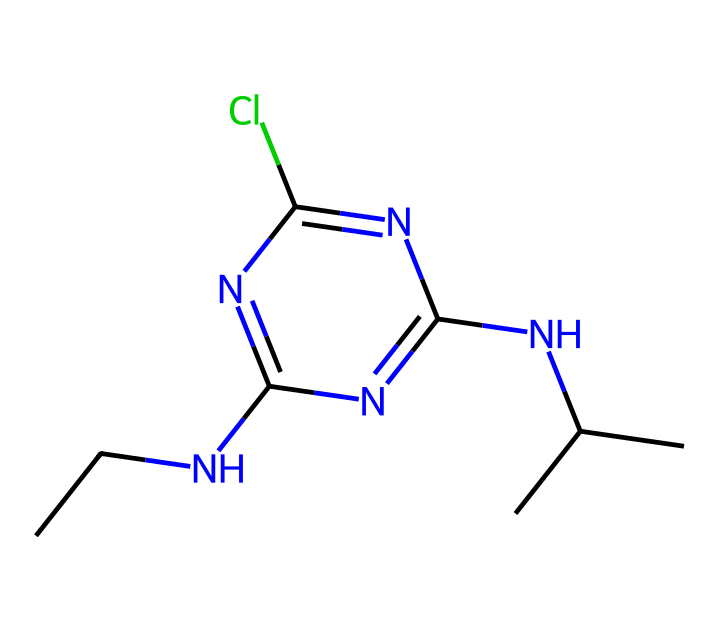What is the molecular formula of atrazine? The molecular formula can be derived from the SMILES representation by identifying the number of each type of atom present. In the provided SMILES, there are 10 carbons (C), 14 hydrogens (H), 3 nitrogens (N), 1 chlorine (Cl). Therefore, the molecular formula is C8H14ClN5.
Answer: C8H14ClN5 How many nitrogen atoms are present in the structure? By analyzing the SMILES representation, we can count the number of nitrogen (N) symbols present, which indicates the nitrogen atoms in the structure. There are a total of three nitrogen atoms.
Answer: 3 What elements are present in atrazine? The elements can be identified from the SMILES notation by recognizing the symbols for each element listed: carbon (C), hydrogen (H), nitrogen (N), and chlorine (Cl). Thus, the elements present in the structure are these four.
Answer: carbon, hydrogen, nitrogen, chlorine Does atrazine contain a chlorine atom? From the SMILES representation, the presence of the "Cl" symbol signifies a chlorine atom is included in the chemical structure. Therefore, the answer is affirmative.
Answer: Yes What type of chemical is atrazine primarily used as? Atrazine is classified as a herbicide based on its purpose in agricultural applications, targeting weeds. Analyzing its structure confirms it contains groups typical of herbicides.
Answer: herbicide How many carbon atoms are in the longest chain of atrazine? To determine the longest carbon chain in the compound, we analyze the structure for connected carbon atoms. This molecule features a branched structure, with the longest continuous chain containing 8 carbon atoms.
Answer: 8 